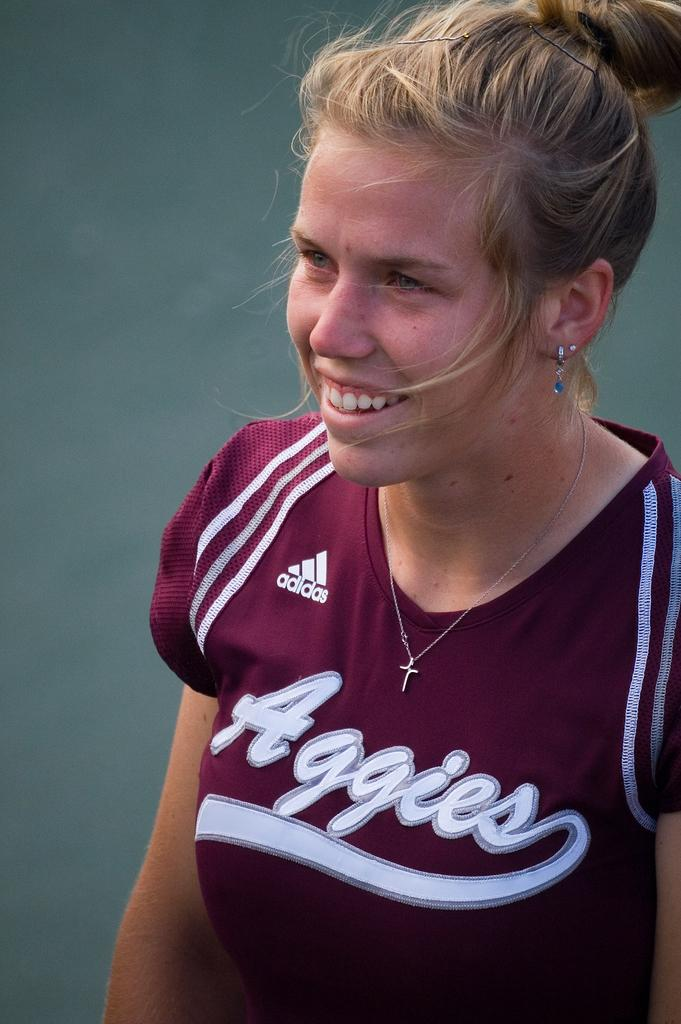<image>
Render a clear and concise summary of the photo. A blonde female smiling with an purple Aggies team shirt 